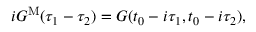<formula> <loc_0><loc_0><loc_500><loc_500>i G ^ { M } ( \tau _ { 1 } - \tau _ { 2 } ) = G ( t _ { 0 } - i \tau _ { 1 } , t _ { 0 } - i \tau _ { 2 } ) ,</formula> 